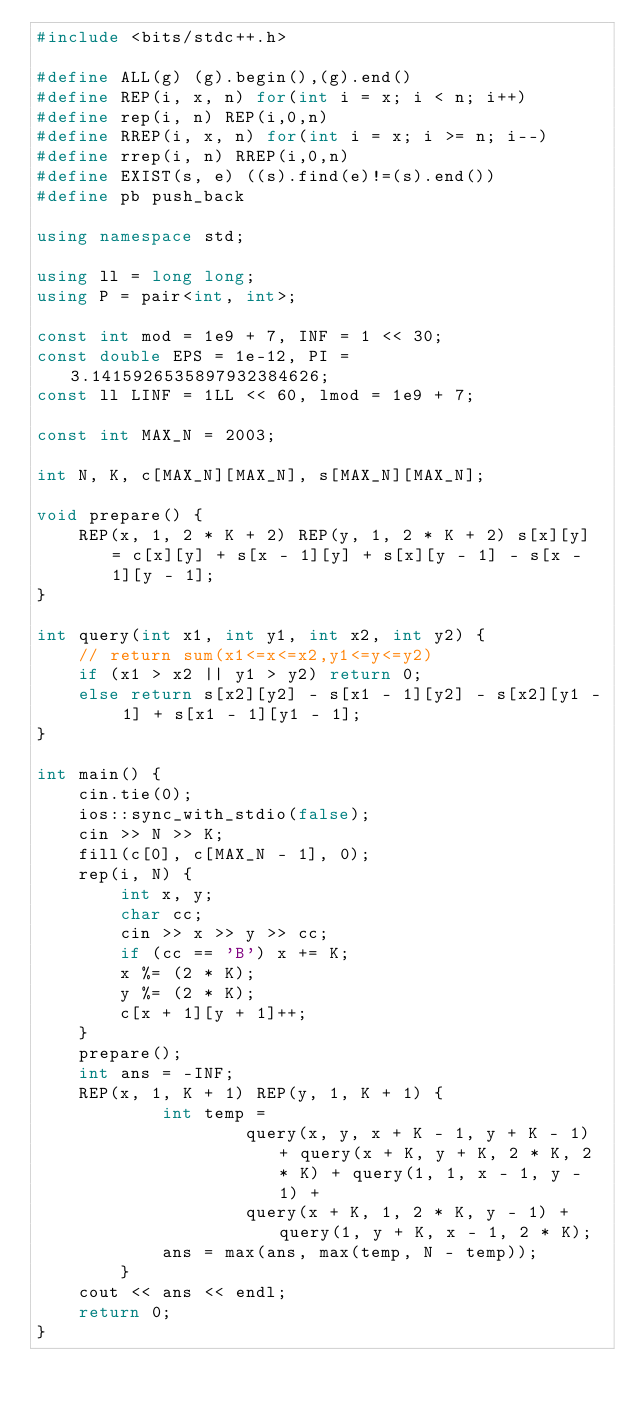<code> <loc_0><loc_0><loc_500><loc_500><_C++_>#include <bits/stdc++.h>

#define ALL(g) (g).begin(),(g).end()
#define REP(i, x, n) for(int i = x; i < n; i++)
#define rep(i, n) REP(i,0,n)
#define RREP(i, x, n) for(int i = x; i >= n; i--)
#define rrep(i, n) RREP(i,0,n)
#define EXIST(s, e) ((s).find(e)!=(s).end())
#define pb push_back

using namespace std;

using ll = long long;
using P = pair<int, int>;

const int mod = 1e9 + 7, INF = 1 << 30;
const double EPS = 1e-12, PI = 3.1415926535897932384626;
const ll LINF = 1LL << 60, lmod = 1e9 + 7;

const int MAX_N = 2003;

int N, K, c[MAX_N][MAX_N], s[MAX_N][MAX_N];

void prepare() {
	REP(x, 1, 2 * K + 2) REP(y, 1, 2 * K + 2) s[x][y] = c[x][y] + s[x - 1][y] + s[x][y - 1] - s[x - 1][y - 1];
}

int query(int x1, int y1, int x2, int y2) {
	// return sum(x1<=x<=x2,y1<=y<=y2)
	if (x1 > x2 || y1 > y2) return 0;
	else return s[x2][y2] - s[x1 - 1][y2] - s[x2][y1 - 1] + s[x1 - 1][y1 - 1];
}

int main() {
	cin.tie(0);
	ios::sync_with_stdio(false);
	cin >> N >> K;
	fill(c[0], c[MAX_N - 1], 0);
	rep(i, N) {
		int x, y;
		char cc;
		cin >> x >> y >> cc;
		if (cc == 'B') x += K;
		x %= (2 * K);
		y %= (2 * K);
		c[x + 1][y + 1]++;
	}
	prepare();
	int ans = -INF;
	REP(x, 1, K + 1) REP(y, 1, K + 1) {
			int temp =
					query(x, y, x + K - 1, y + K - 1) + query(x + K, y + K, 2 * K, 2 * K) + query(1, 1, x - 1, y - 1) +
					query(x + K, 1, 2 * K, y - 1) + query(1, y + K, x - 1, 2 * K);
			ans = max(ans, max(temp, N - temp));
		}
	cout << ans << endl;
	return 0;
}</code> 